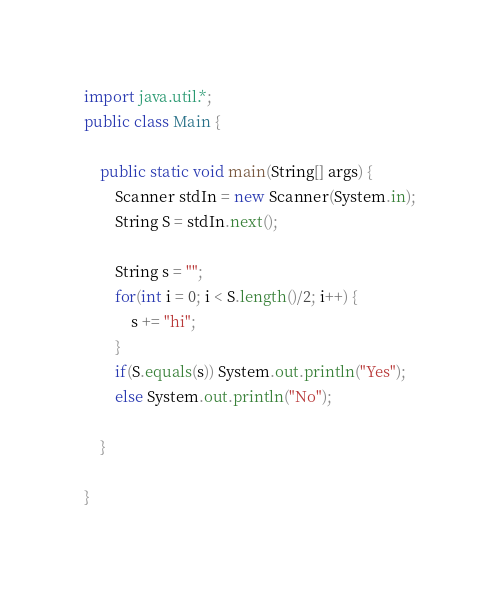Convert code to text. <code><loc_0><loc_0><loc_500><loc_500><_Java_>import java.util.*;
public class Main {

	public static void main(String[] args) {
		Scanner stdIn = new Scanner(System.in);
		String S = stdIn.next();
		
		String s = "";
		for(int i = 0; i < S.length()/2; i++) {
			s += "hi";
		}
		if(S.equals(s)) System.out.println("Yes");
		else System.out.println("No");

	}

}</code> 